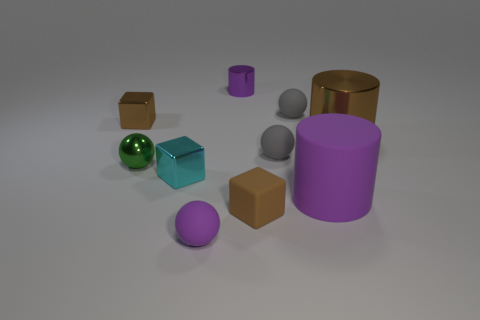Subtract all spheres. How many objects are left? 6 Subtract 0 blue cylinders. How many objects are left? 10 Subtract all rubber cubes. Subtract all yellow matte cubes. How many objects are left? 9 Add 3 small gray rubber objects. How many small gray rubber objects are left? 5 Add 4 small gray balls. How many small gray balls exist? 6 